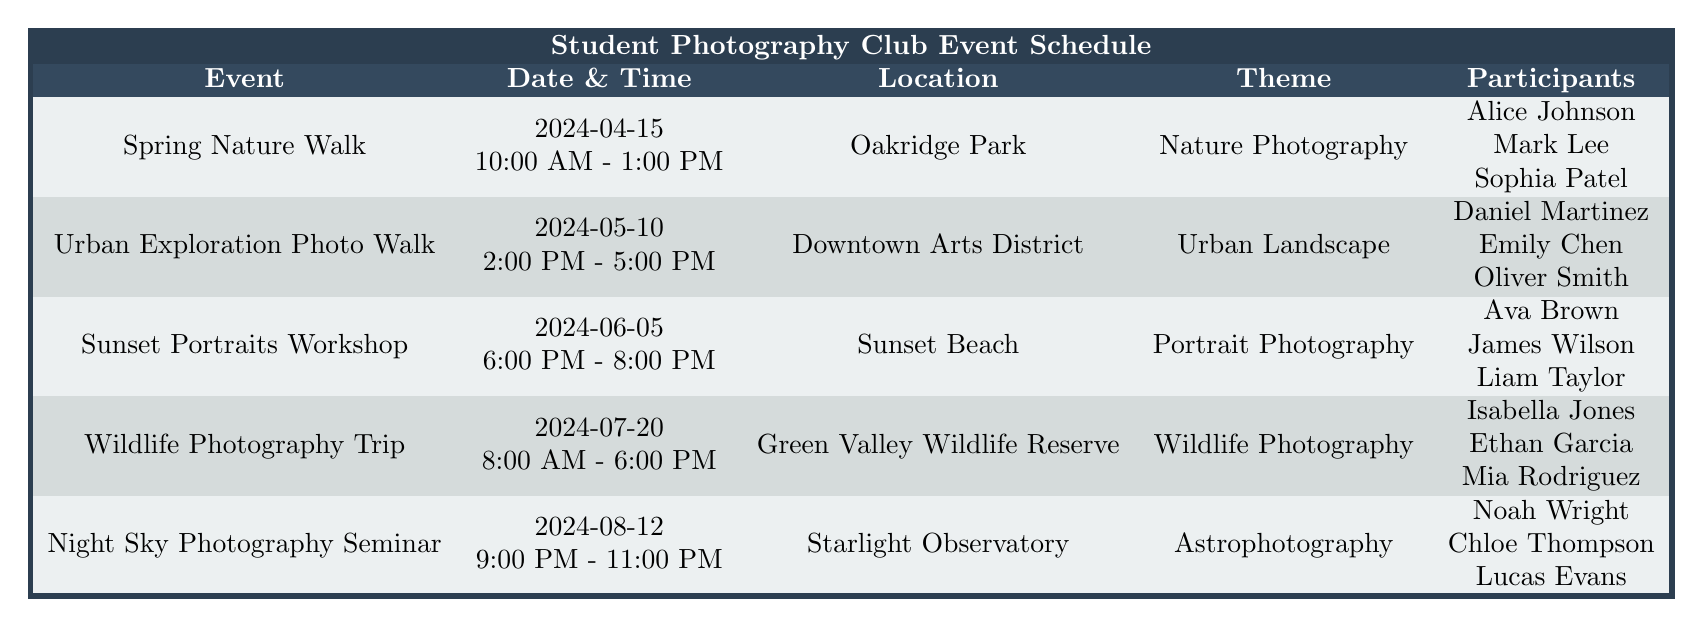What is the location for the Spring Nature Walk? Looking at the row for the Spring Nature Walk, the location listed is Oakridge Park.
Answer: Oakridge Park Who are the participants in the Wildlife Photography Trip? The participants listed for the Wildlife Photography Trip are Isabella Jones, Ethan Garcia, and Mia Rodriguez.
Answer: Isabella Jones, Ethan Garcia, Mia Rodriguez When is the Urban Exploration Photo Walk scheduled to take place? The Urban Exploration Photo Walk is scheduled for May 10, 2024, as indicated in the date column of that event.
Answer: May 10, 2024 What is the theme of the Sunset Portraits Workshop? The theme listed for the Sunset Portraits Workshop is Portrait Photography, which can be found in the corresponding column for that event.
Answer: Portrait Photography How many events are scheduled for the month of June 2024? There is one event scheduled for June 2024, which is the Sunset Portraits Workshop on June 5.
Answer: 1 Which event starts at 9:00 PM? The Night Sky Photography Seminar starts at 9:00 PM, as shown in the time column for that event.
Answer: Night Sky Photography Seminar Are there any events focused on Nature Photography? Yes, the Spring Nature Walk is focused on Nature Photography, as indicated under the theme for that event.
Answer: Yes What is the time duration of the Wildlife Photography Trip? The Wildlife Photography Trip runs from 8:00 AM to 6:00 PM, giving it a total duration of 10 hours.
Answer: 10 hours Which event has the latest end time? The Wildlife Photography Trip ends at 6:00 PM, and when comparing with other events, no other event ends later than this.
Answer: Wildlife Photography Trip What is the total number of participants across all events listed? Summing the participants from each event: 3 (Spring Nature Walk) + 3 (Urban Exploration Photo Walk) + 3 (Sunset Portraits Workshop) + 3 (Wildlife Photography Trip) + 3 (Night Sky Photography Seminar) = 15 participants total.
Answer: 15 How many participants are in the Urban Exploration Photo Walk if we exclude their names? The Urban Exploration Photo Walk has 3 participants, and excluding their names, the count remains 3.
Answer: 3 Is there an event with a theme related to Astrophotography? Yes, the Night Sky Photography Seminar has a theme related to Astrophotography.
Answer: Yes What is the earliest event in the schedule? The earliest event in the schedule is the Spring Nature Walk on April 15, 2024.
Answer: Spring Nature Walk 